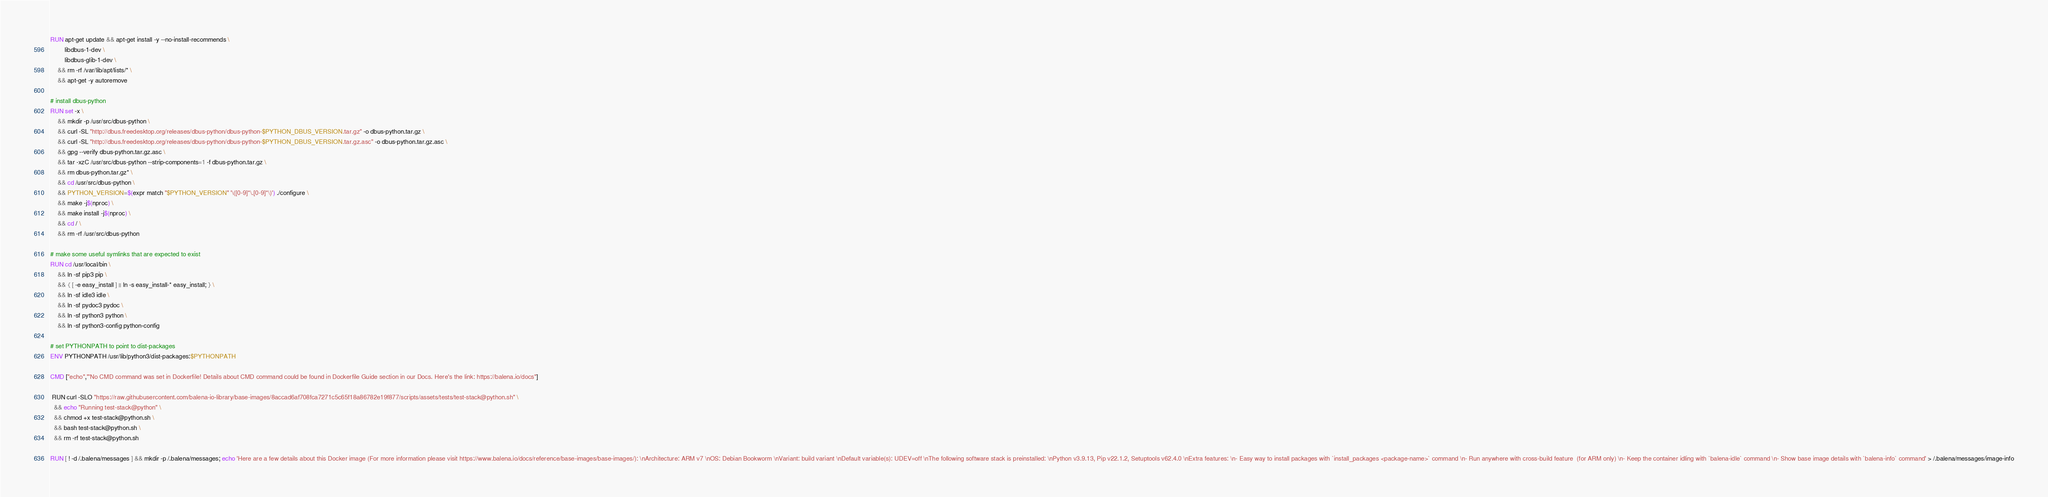<code> <loc_0><loc_0><loc_500><loc_500><_Dockerfile_>RUN apt-get update && apt-get install -y --no-install-recommends \
		libdbus-1-dev \
		libdbus-glib-1-dev \
	&& rm -rf /var/lib/apt/lists/* \
	&& apt-get -y autoremove

# install dbus-python
RUN set -x \
	&& mkdir -p /usr/src/dbus-python \
	&& curl -SL "http://dbus.freedesktop.org/releases/dbus-python/dbus-python-$PYTHON_DBUS_VERSION.tar.gz" -o dbus-python.tar.gz \
	&& curl -SL "http://dbus.freedesktop.org/releases/dbus-python/dbus-python-$PYTHON_DBUS_VERSION.tar.gz.asc" -o dbus-python.tar.gz.asc \
	&& gpg --verify dbus-python.tar.gz.asc \
	&& tar -xzC /usr/src/dbus-python --strip-components=1 -f dbus-python.tar.gz \
	&& rm dbus-python.tar.gz* \
	&& cd /usr/src/dbus-python \
	&& PYTHON_VERSION=$(expr match "$PYTHON_VERSION" '\([0-9]*\.[0-9]*\)') ./configure \
	&& make -j$(nproc) \
	&& make install -j$(nproc) \
	&& cd / \
	&& rm -rf /usr/src/dbus-python

# make some useful symlinks that are expected to exist
RUN cd /usr/local/bin \
	&& ln -sf pip3 pip \
	&& { [ -e easy_install ] || ln -s easy_install-* easy_install; } \
	&& ln -sf idle3 idle \
	&& ln -sf pydoc3 pydoc \
	&& ln -sf python3 python \
	&& ln -sf python3-config python-config

# set PYTHONPATH to point to dist-packages
ENV PYTHONPATH /usr/lib/python3/dist-packages:$PYTHONPATH

CMD ["echo","'No CMD command was set in Dockerfile! Details about CMD command could be found in Dockerfile Guide section in our Docs. Here's the link: https://balena.io/docs"]

 RUN curl -SLO "https://raw.githubusercontent.com/balena-io-library/base-images/8accad6af708fca7271c5c65f18a86782e19f877/scripts/assets/tests/test-stack@python.sh" \
  && echo "Running test-stack@python" \
  && chmod +x test-stack@python.sh \
  && bash test-stack@python.sh \
  && rm -rf test-stack@python.sh 

RUN [ ! -d /.balena/messages ] && mkdir -p /.balena/messages; echo 'Here are a few details about this Docker image (For more information please visit https://www.balena.io/docs/reference/base-images/base-images/): \nArchitecture: ARM v7 \nOS: Debian Bookworm \nVariant: build variant \nDefault variable(s): UDEV=off \nThe following software stack is preinstalled: \nPython v3.9.13, Pip v22.1.2, Setuptools v62.4.0 \nExtra features: \n- Easy way to install packages with `install_packages <package-name>` command \n- Run anywhere with cross-build feature  (for ARM only) \n- Keep the container idling with `balena-idle` command \n- Show base image details with `balena-info` command' > /.balena/messages/image-info</code> 